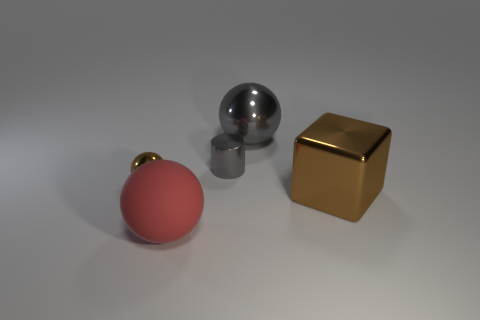Add 3 big shiny things. How many objects exist? 8 Subtract all blocks. How many objects are left? 4 Add 1 big cubes. How many big cubes are left? 2 Add 4 big blue metal cylinders. How many big blue metal cylinders exist? 4 Subtract 0 green spheres. How many objects are left? 5 Subtract all metallic cubes. Subtract all small purple shiny things. How many objects are left? 4 